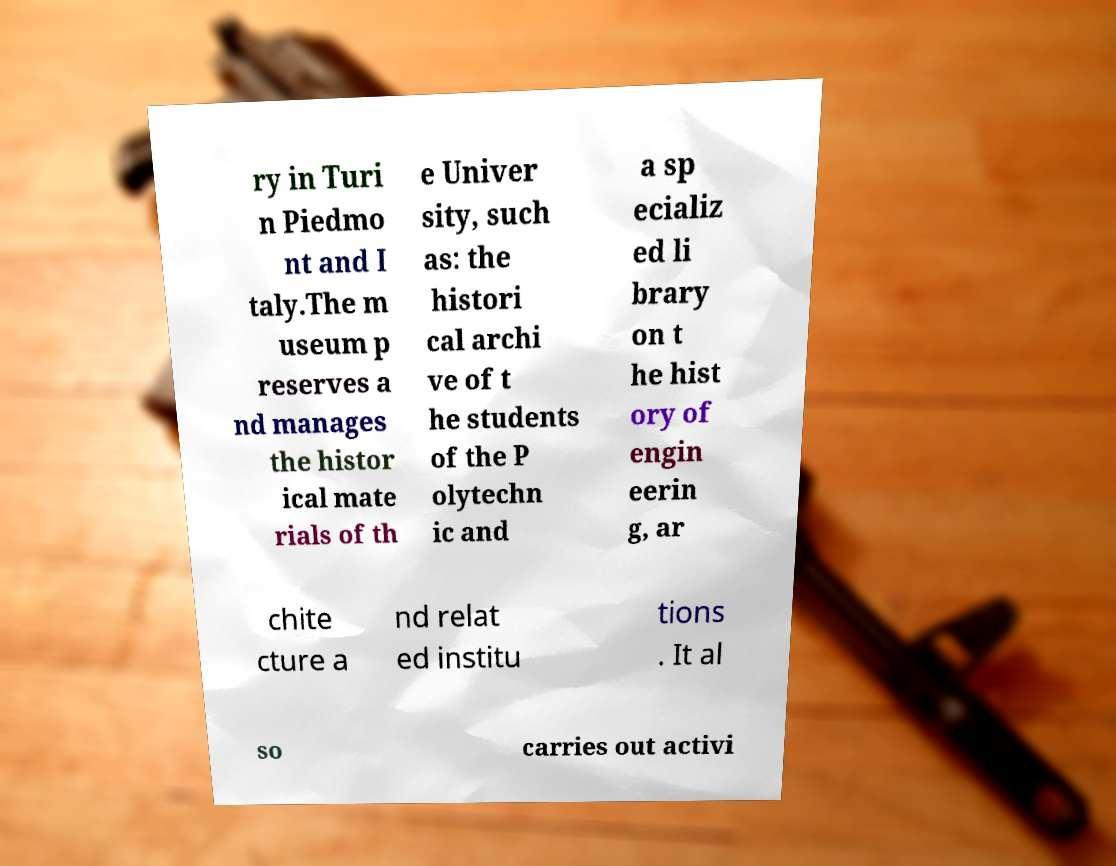Could you extract and type out the text from this image? ry in Turi n Piedmo nt and I taly.The m useum p reserves a nd manages the histor ical mate rials of th e Univer sity, such as: the histori cal archi ve of t he students of the P olytechn ic and a sp ecializ ed li brary on t he hist ory of engin eerin g, ar chite cture a nd relat ed institu tions . It al so carries out activi 